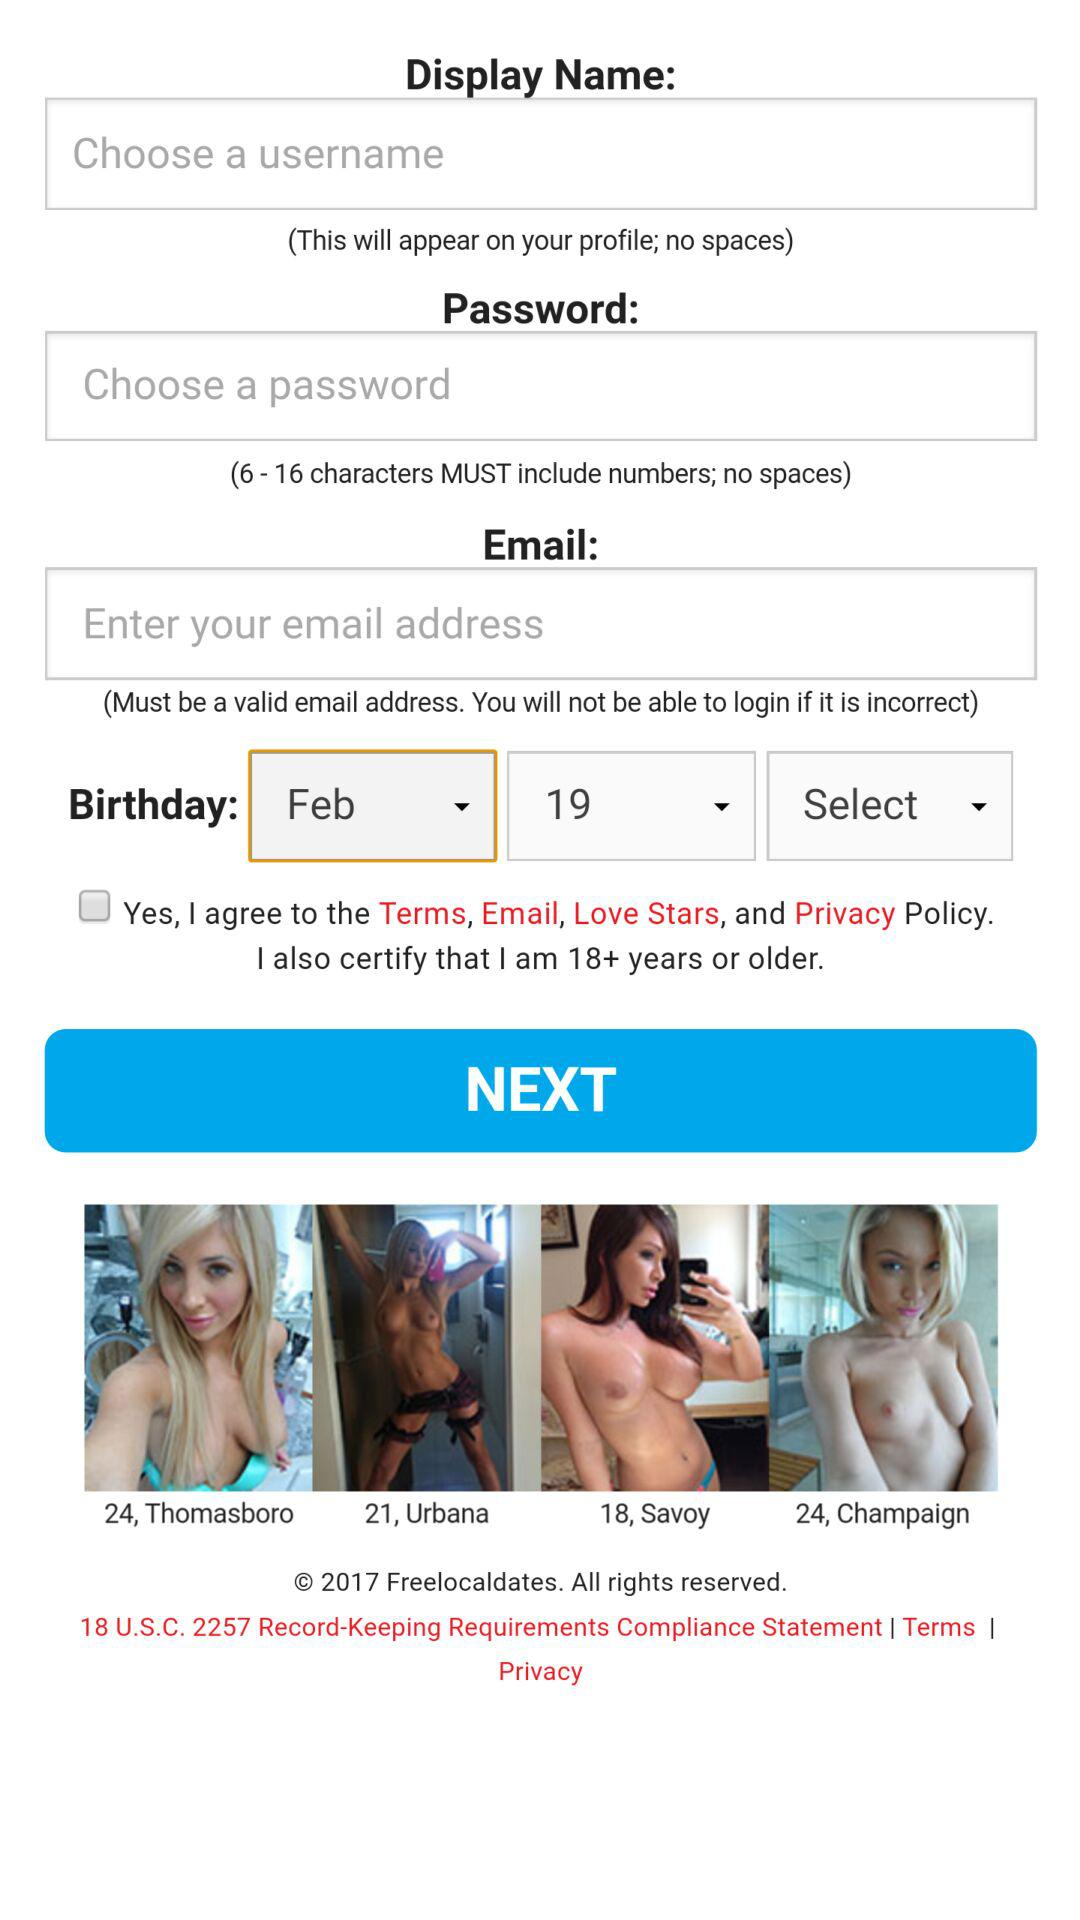What is the year of copyright for the application? The year of copyright is 2017. 